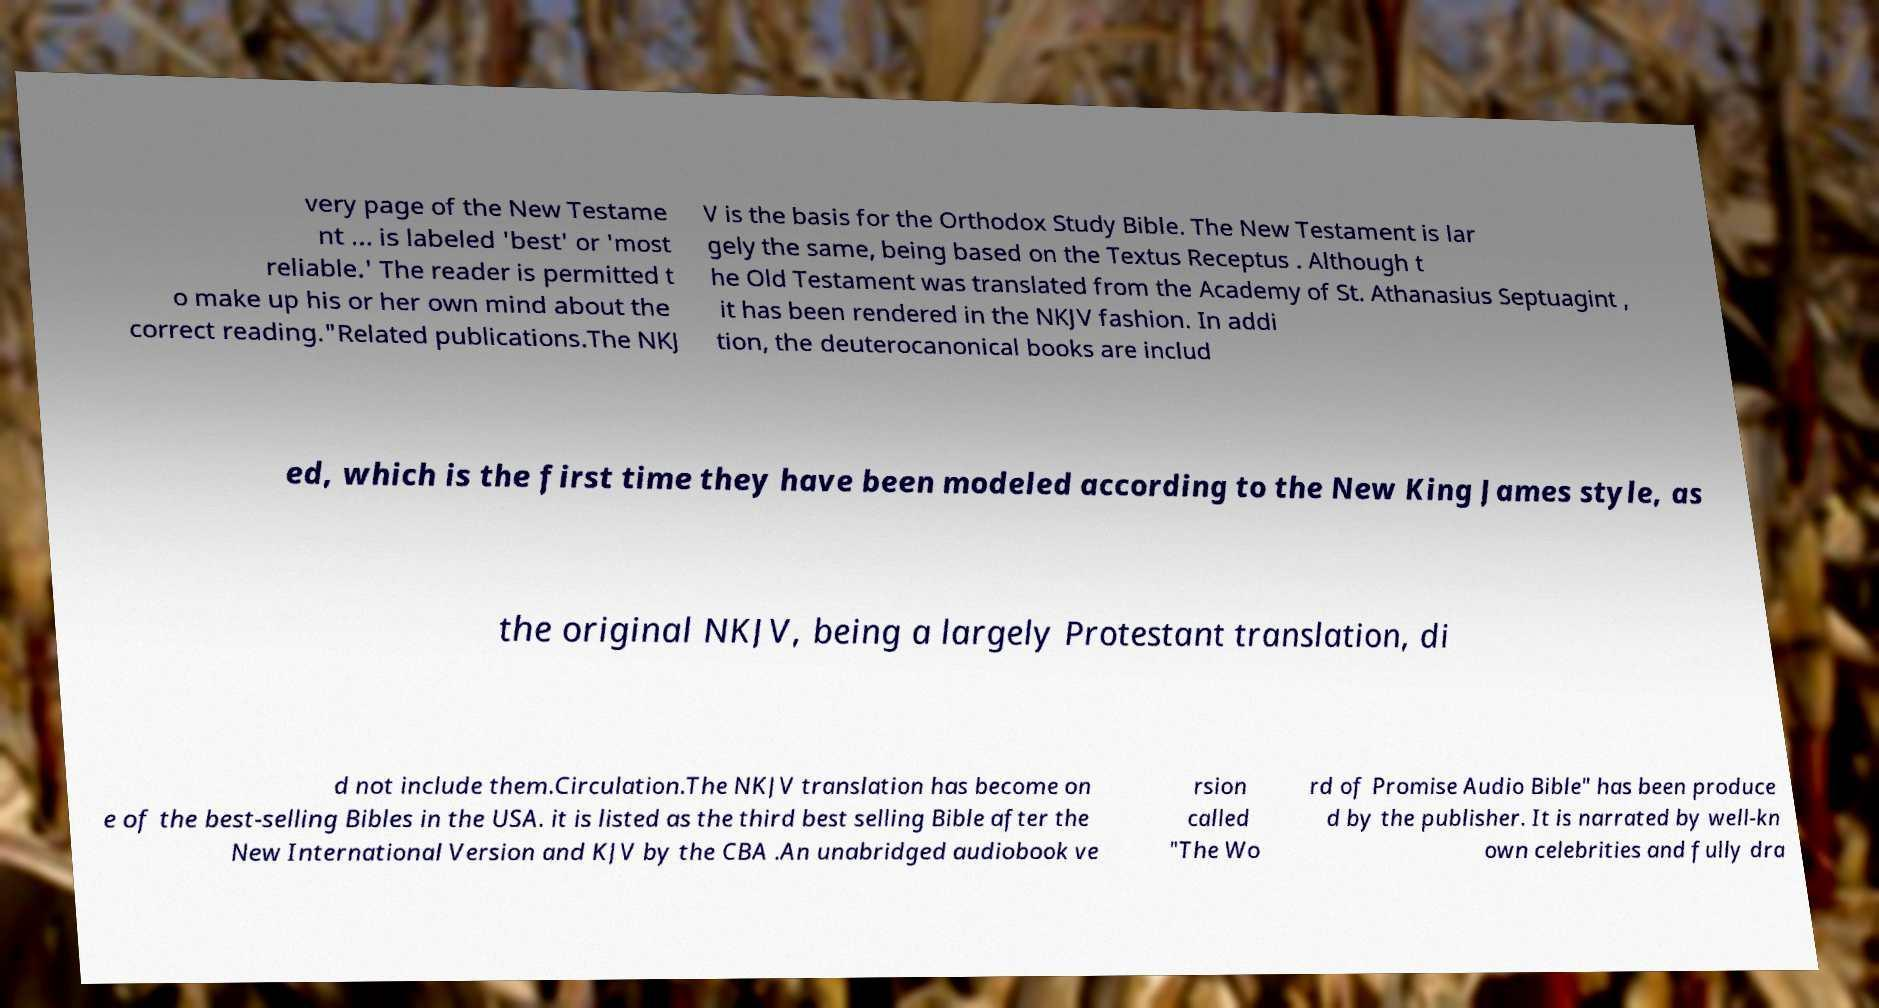Could you extract and type out the text from this image? very page of the New Testame nt ... is labeled 'best' or 'most reliable.' The reader is permitted t o make up his or her own mind about the correct reading."Related publications.The NKJ V is the basis for the Orthodox Study Bible. The New Testament is lar gely the same, being based on the Textus Receptus . Although t he Old Testament was translated from the Academy of St. Athanasius Septuagint , it has been rendered in the NKJV fashion. In addi tion, the deuterocanonical books are includ ed, which is the first time they have been modeled according to the New King James style, as the original NKJV, being a largely Protestant translation, di d not include them.Circulation.The NKJV translation has become on e of the best-selling Bibles in the USA. it is listed as the third best selling Bible after the New International Version and KJV by the CBA .An unabridged audiobook ve rsion called "The Wo rd of Promise Audio Bible" has been produce d by the publisher. It is narrated by well-kn own celebrities and fully dra 